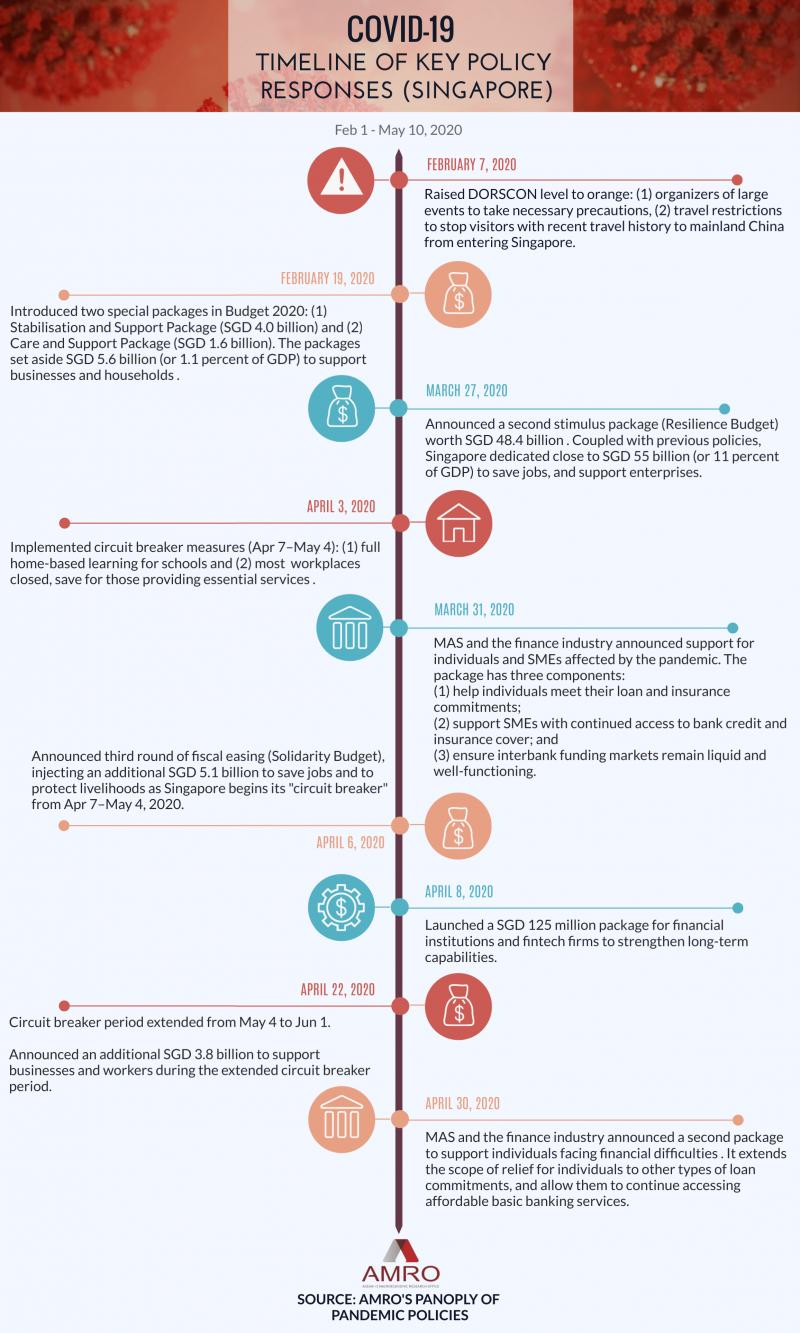Point out several critical features in this image. Thirteen packages were introduced before April 3. 